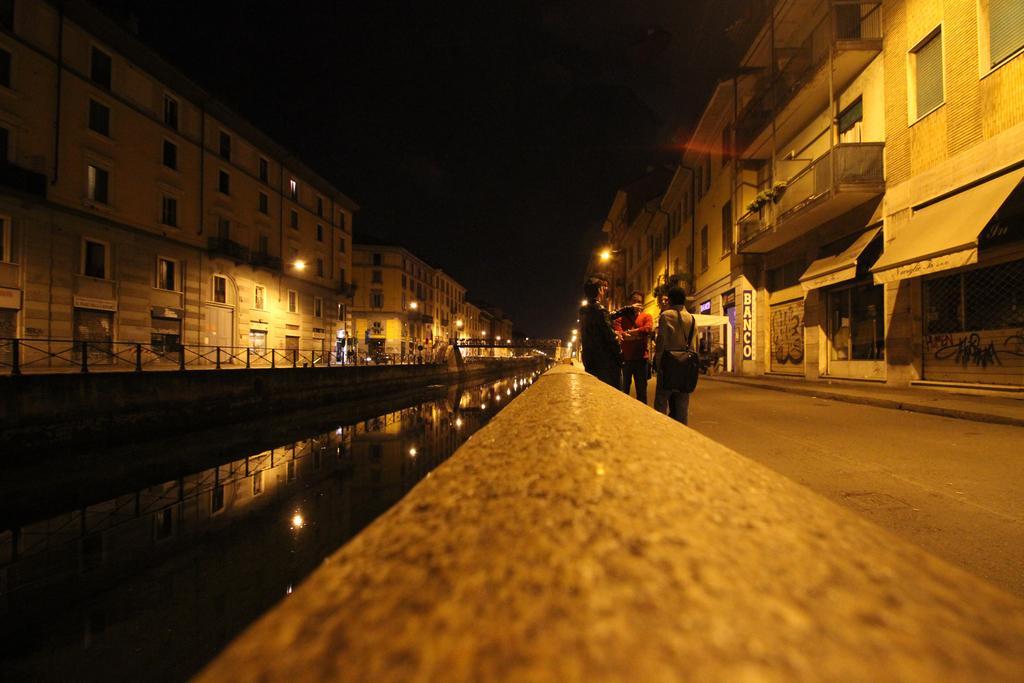Can you describe this image briefly? In this picture I can see the group of persons who are standing near to the wall. Beside them I can see the building. On the left I can see many buildings, fencing, street lights and other objects. In the center I can see the water. At the top I can see the darkness. 